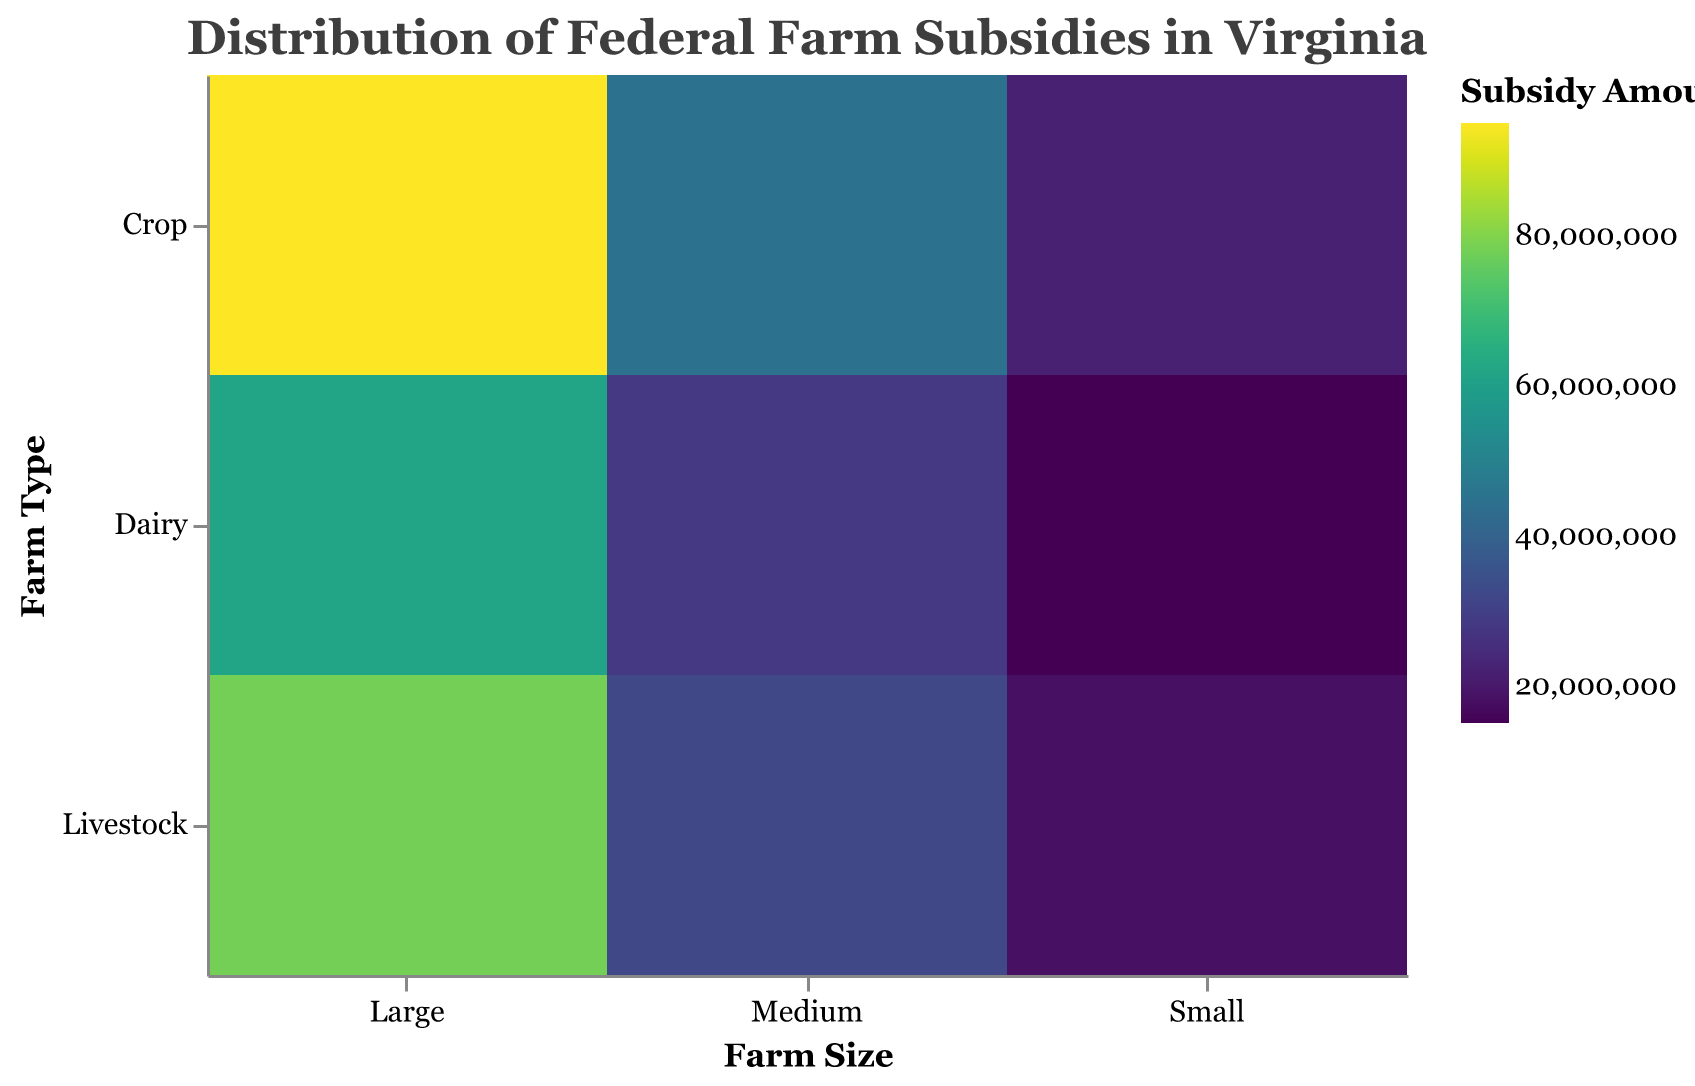Which farm size category receives the highest federal farm subsidies? The Large farm size category shows the darkest shades representing higher subsidy amounts in the plot.
Answer: Large What is the total federal subsidy amount for Dairy farms across all sizes? Sum the subsidy amounts for Dairy farms in each size category: 15,000,000 (Small) + 28,000,000 (Medium) + 62,000,000 (Large) = 105,000,000.
Answer: 105,000,000 Are small crop farms receiving more subsidies than small livestock farms? Compare the subsidy amounts shown for Small Crop farms and Small Livestock farms. Small Crop farms receive 22M, and Small Livestock farms receive 18M.
Answer: Yes Which farm type receives the least amount of subsidies within the medium farm size category? Among Medium farm sizes, Livestock has the lowest subsidy amount shown, which is 32,000,000 compared to Dairy (28,000,000) and Crop (45,000,000).
Answer: Dairy What is the difference in federal subsidies between Large Dairy farms and Medium Dairy farms? Subtract the subsidy amount of Medium Dairy farms (28,000,000) from that of Large Dairy farms (62,000,000): 62,000,000 - 28,000,000 = 34,000,000.
Answer: 34,000,000 Which combination of farm size and type receives the greatest subsidy amount? The darkest color in the plot, which indicates the greatest subsidy, is seen for Large Crop farms.
Answer: Large Crop How do subsidies for medium-sized Livestock farms compare to small-sized Livestock farms? Medium-sized Livestock farms have a subsidy of 32,000,000, while small-sized Livestock farms receive 18,000,000.
Answer: Medium-sized have more What is the overall trend for subsidies with increasing farm sizes within each farm type? Observing the colors from small to large farm sizes, subsidies consistently increase across all types (Dairy, Crop, Livestock).
Answer: Increasing How much more subsidy do large Crop farms receive compared to large Livestock farms? Subtract the subsidy amount of Large Livestock farms (78,000,000) from Large Crop farms (95,000,000): 95,000,000 - 78,000,000 = 17,000,000.
Answer: 17,000,000 Which farm size category receives almost double the subsidy amount of the small farm size category in Dairy? The Large farm size category receives 62,000,000, which is more than double the 15,000,000 received by the Small category.
Answer: Large 